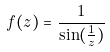Convert formula to latex. <formula><loc_0><loc_0><loc_500><loc_500>f ( z ) = \frac { 1 } { \sin ( \frac { 1 } { z } ) }</formula> 